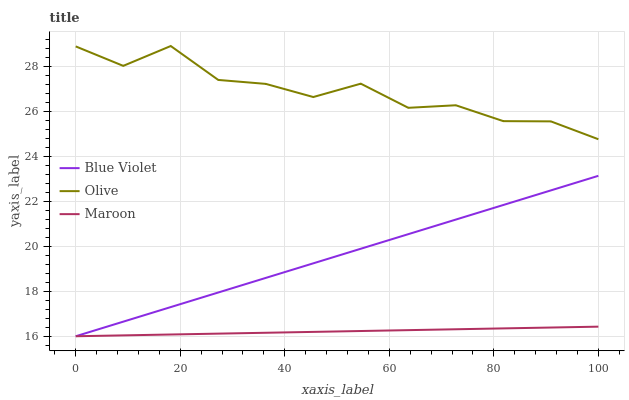Does Maroon have the minimum area under the curve?
Answer yes or no. Yes. Does Olive have the maximum area under the curve?
Answer yes or no. Yes. Does Blue Violet have the minimum area under the curve?
Answer yes or no. No. Does Blue Violet have the maximum area under the curve?
Answer yes or no. No. Is Maroon the smoothest?
Answer yes or no. Yes. Is Olive the roughest?
Answer yes or no. Yes. Is Blue Violet the smoothest?
Answer yes or no. No. Is Blue Violet the roughest?
Answer yes or no. No. Does Maroon have the lowest value?
Answer yes or no. Yes. Does Olive have the highest value?
Answer yes or no. Yes. Does Blue Violet have the highest value?
Answer yes or no. No. Is Maroon less than Olive?
Answer yes or no. Yes. Is Olive greater than Maroon?
Answer yes or no. Yes. Does Maroon intersect Blue Violet?
Answer yes or no. Yes. Is Maroon less than Blue Violet?
Answer yes or no. No. Is Maroon greater than Blue Violet?
Answer yes or no. No. Does Maroon intersect Olive?
Answer yes or no. No. 